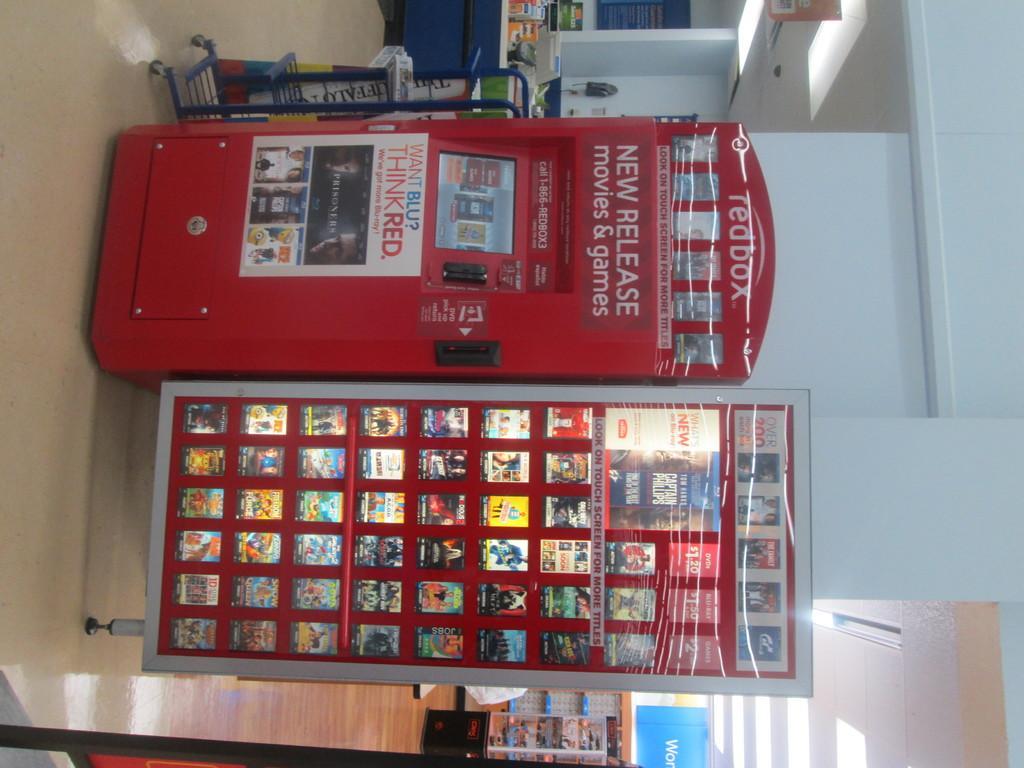Please provide a concise description of this image. In this picture we can see a machine and hoardings, in the background we can find few things on the countertop and few lights. 